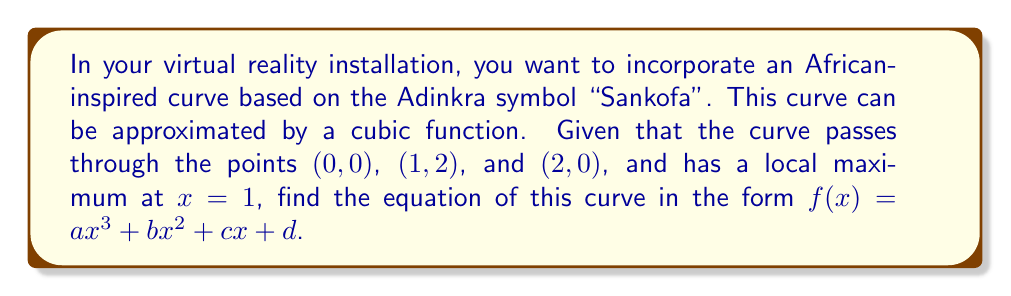Show me your answer to this math problem. Let's approach this step-by-step:

1) The general form of our cubic function is $f(x) = ax^3 + bx^2 + cx + d$.

2) We know the curve passes through (0, 0), so:
   $f(0) = 0 = a(0)^3 + b(0)^2 + c(0) + d$
   Therefore, $d = 0$

3) The curve passes through (1, 2):
   $f(1) = 2 = a(1)^3 + b(1)^2 + c(1) + 0$
   $2 = a + b + c$ ... (Equation 1)

4) The curve passes through (2, 0):
   $f(2) = 0 = a(2)^3 + b(2)^2 + c(2) + 0$
   $0 = 8a + 4b + 2c$ ... (Equation 2)

5) The curve has a local maximum at x = 1. This means the derivative $f'(x)$ is zero at x = 1:
   $f'(x) = 3ax^2 + 2bx + c$
   $f'(1) = 0 = 3a + 2b + c$ ... (Equation 3)

6) Now we have a system of three equations:
   $2 = a + b + c$
   $0 = 8a + 4b + 2c$
   $0 = 3a + 2b + c$

7) Subtracting Equation 3 from Equation 1:
   $2 = -2a - b$
   $b = -2a - 2$ ... (Equation 4)

8) Substituting this into Equation 3:
   $0 = 3a + 2(-2a - 2) + c$
   $0 = 3a - 4a - 4 + c$
   $c = -a + 4$ ... (Equation 5)

9) Substituting Equations 4 and 5 into Equation 2:
   $0 = 8a + 4(-2a - 2) + 2(-a + 4)$
   $0 = 8a - 8a - 8 - 2a + 8$
   $0 = -2a$
   $a = 0$

10) Substituting $a = 0$ back into Equations 4 and 5:
    $b = -2$
    $c = 4$

Therefore, the equation of the curve is $f(x) = -2x^2 + 4x$.
Answer: $f(x) = -2x^2 + 4x$ 